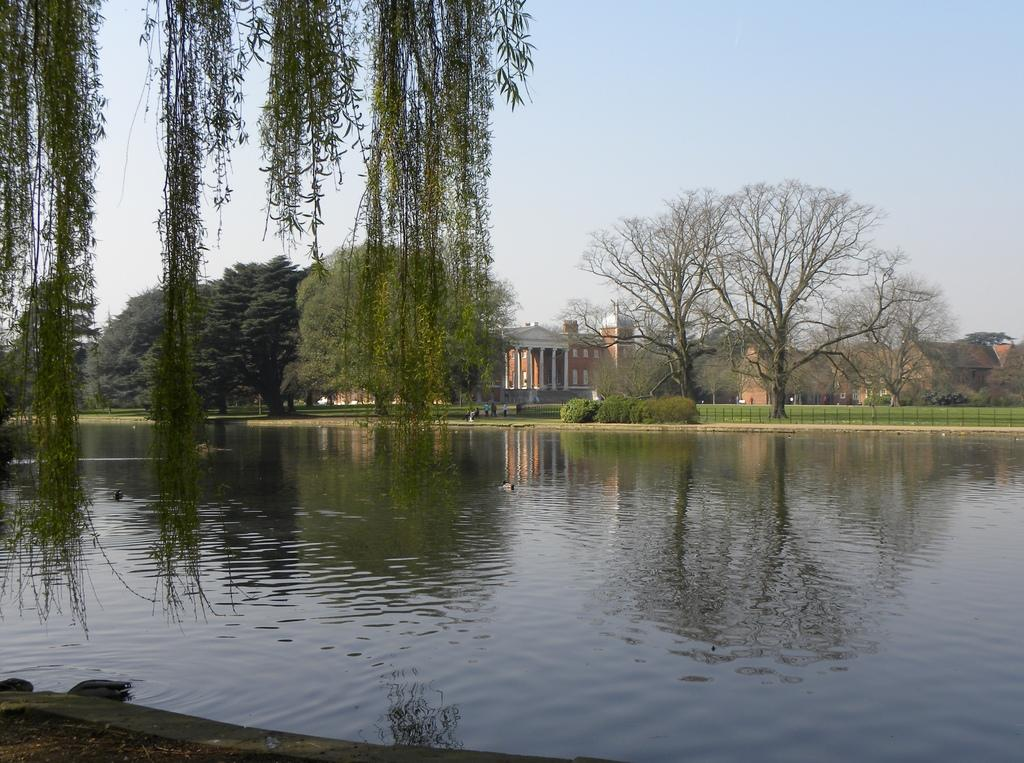What type of natural feature can be seen in the image? There is a river in the image. What is the primary substance visible in the image? There is water visible in the image. What type of vegetation is present in the image? There are green color trees in the image. What type of structure can be seen in the image? There is a house in the image. What is visible in the background of the image? The sky is visible in the image. What is the condition of the sky in the image? The sky is cloudy in the image. How many balls are being used in the conversation in the image? There are no balls or conversations present in the image; it features a river, water, green trees, a house, and a cloudy sky. What type of lake is visible in the image? There is no lake present in the image; it features a river instead. 